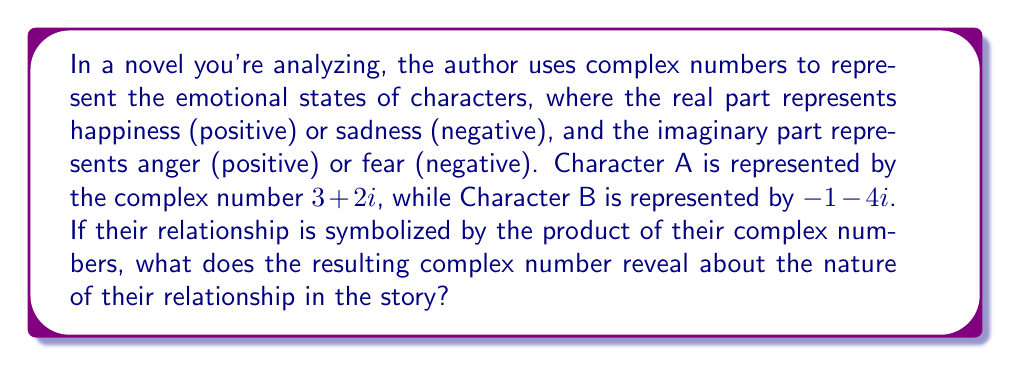What is the answer to this math problem? To solve this problem, we need to multiply the two complex numbers representing Character A and Character B. Let's break it down step-by-step:

1) Character A: $z_1 = 3 + 2i$
   Character B: $z_2 = -1 - 4i$

2) To multiply complex numbers, we use the distributive property and the fact that $i^2 = -1$:

   $z_1 \cdot z_2 = (3 + 2i)(-1 - 4i)$
   
   $= -3 - 12i + (-2i - 8i^2)$
   
   $= -3 - 12i - 2i + 8$ (because $i^2 = -1$)
   
   $= 5 - 14i$

3) Interpreting the result:
   - The real part (5) is positive, indicating a net positive happiness in the relationship.
   - The imaginary part (-14i) is negative and has a larger magnitude than the real part, indicating significant fear or anxiety in the relationship.

4) In the context of literary analysis, this could be interpreted as a relationship that brings some happiness or contentment (positive real part) but is overshadowed by deep-seated fears or anxieties (large negative imaginary part). The characters might find some joy in their interactions, but there's an underlying tension or worry that dominates their relationship.
Answer: The resulting complex number is $5 - 14i$, which suggests a relationship characterized by moderate happiness but overshadowed by significant fear or anxiety. 